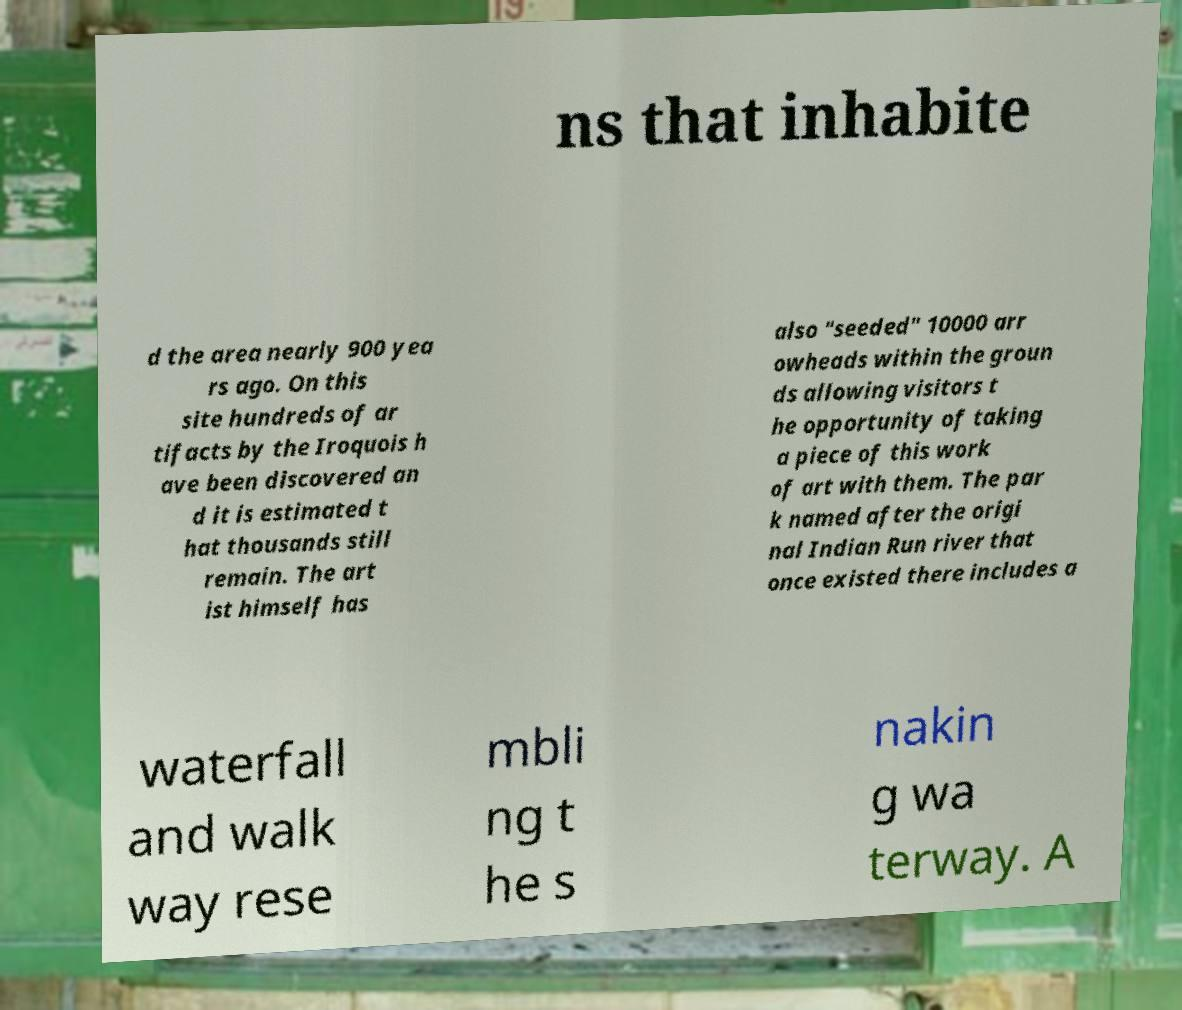Please read and relay the text visible in this image. What does it say? ns that inhabite d the area nearly 900 yea rs ago. On this site hundreds of ar tifacts by the Iroquois h ave been discovered an d it is estimated t hat thousands still remain. The art ist himself has also "seeded" 10000 arr owheads within the groun ds allowing visitors t he opportunity of taking a piece of this work of art with them. The par k named after the origi nal Indian Run river that once existed there includes a waterfall and walk way rese mbli ng t he s nakin g wa terway. A 